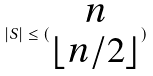Convert formula to latex. <formula><loc_0><loc_0><loc_500><loc_500>| S | \leq ( \begin{matrix} n \\ \lfloor n / 2 \rfloor \end{matrix} )</formula> 